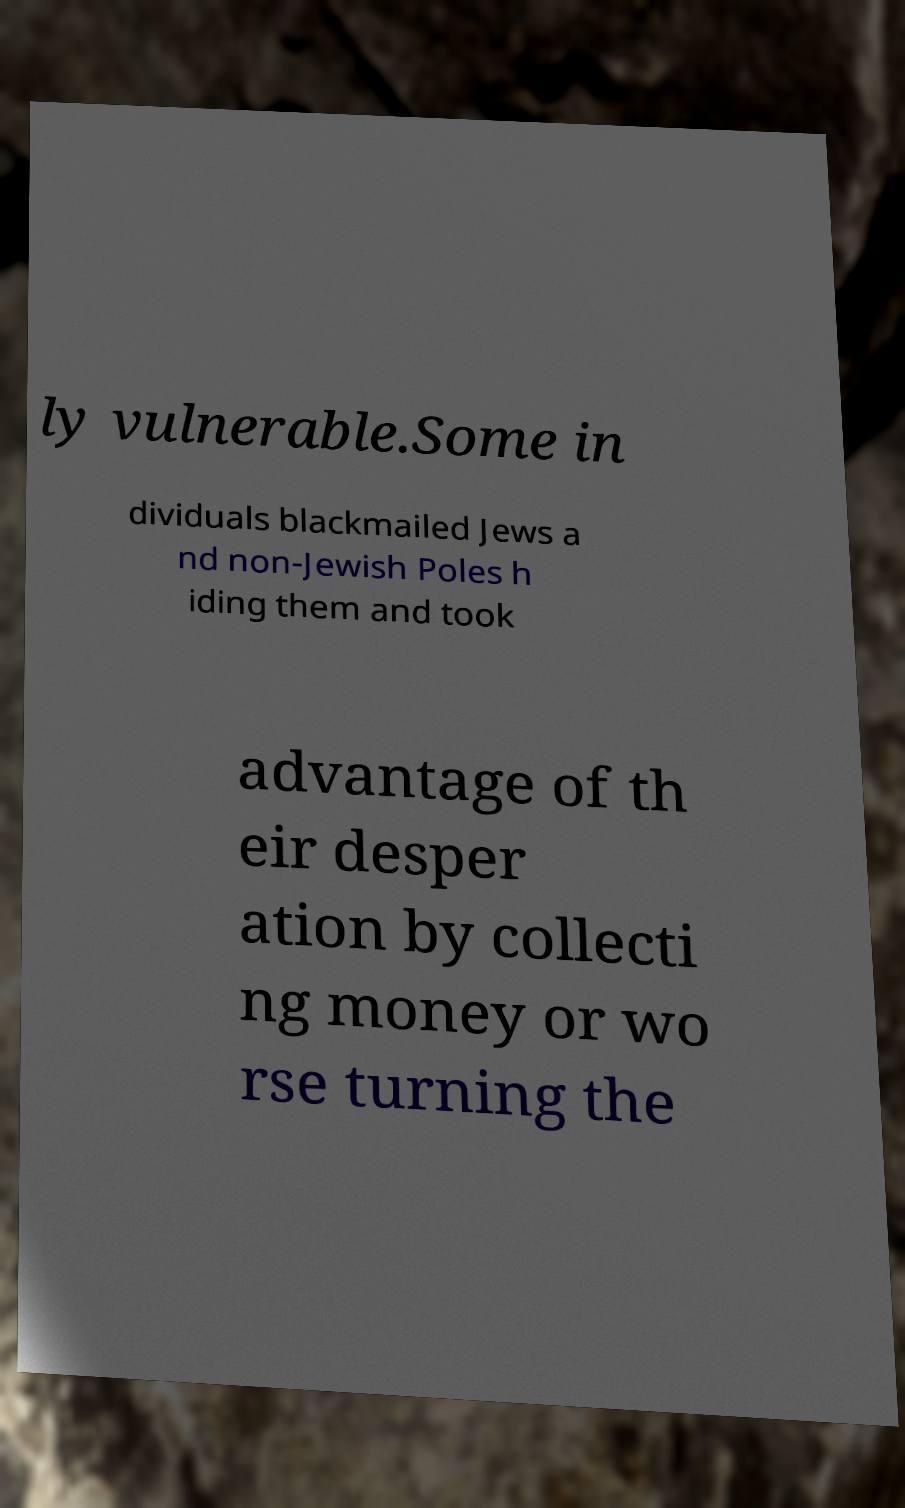There's text embedded in this image that I need extracted. Can you transcribe it verbatim? ly vulnerable.Some in dividuals blackmailed Jews a nd non-Jewish Poles h iding them and took advantage of th eir desper ation by collecti ng money or wo rse turning the 